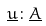<formula> <loc_0><loc_0><loc_500><loc_500>\underline { u } \colon \underline { A }</formula> 